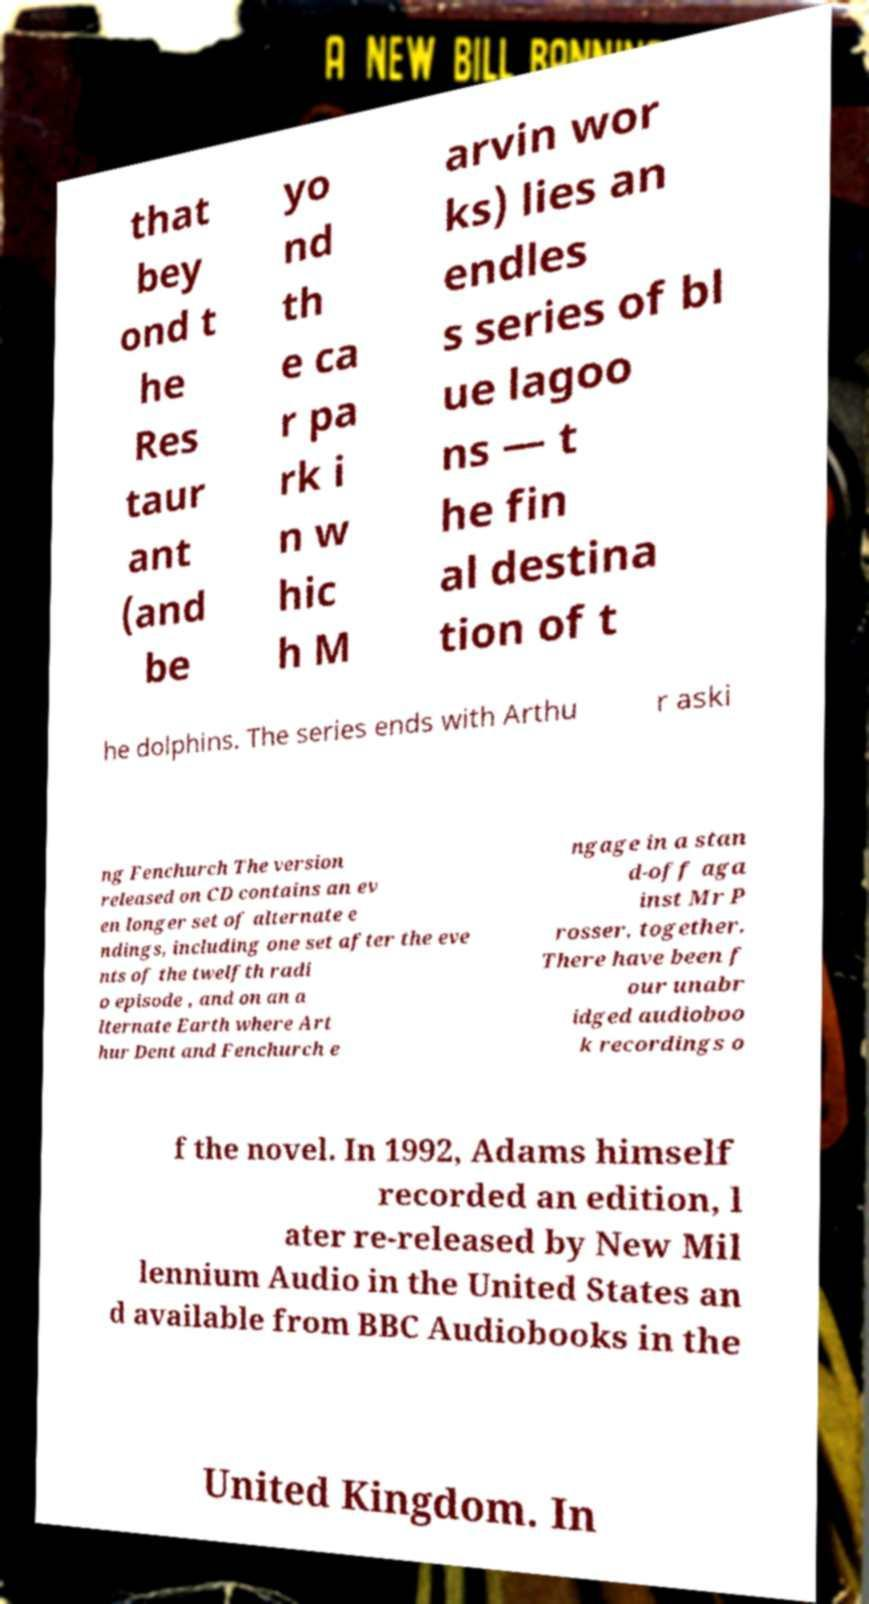There's text embedded in this image that I need extracted. Can you transcribe it verbatim? that bey ond t he Res taur ant (and be yo nd th e ca r pa rk i n w hic h M arvin wor ks) lies an endles s series of bl ue lagoo ns — t he fin al destina tion of t he dolphins. The series ends with Arthu r aski ng Fenchurch The version released on CD contains an ev en longer set of alternate e ndings, including one set after the eve nts of the twelfth radi o episode , and on an a lternate Earth where Art hur Dent and Fenchurch e ngage in a stan d-off aga inst Mr P rosser, together. There have been f our unabr idged audioboo k recordings o f the novel. In 1992, Adams himself recorded an edition, l ater re-released by New Mil lennium Audio in the United States an d available from BBC Audiobooks in the United Kingdom. In 